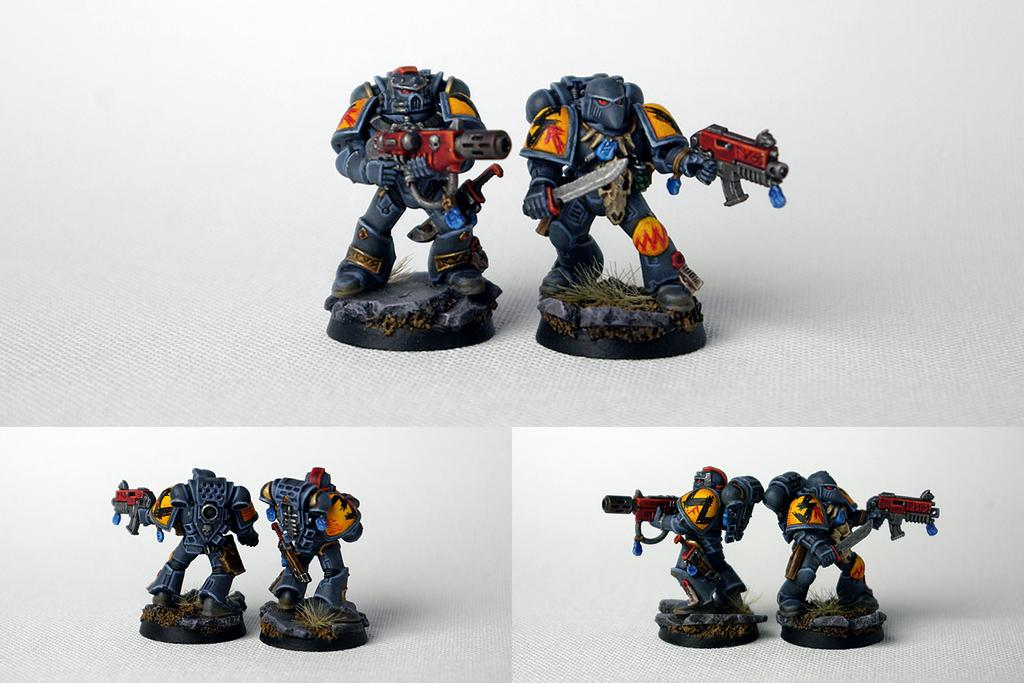What objects are present in the image? There are toys in the image. What are the toys doing in the image? The toys are holding weapons and standing. Can you describe the appearance of the image? The image appears to be edited. How do the girls react to the surprise in the image? There are no girls present in the image, and there is no mention of a surprise. 